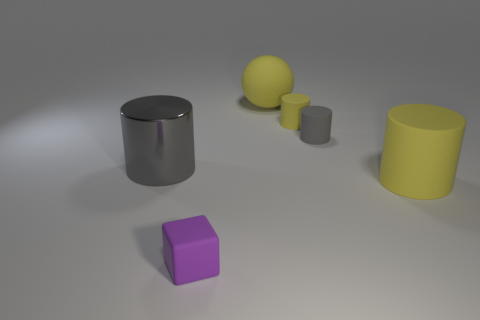Are there any other things that have the same material as the large gray cylinder?
Offer a very short reply. No. What number of things are either yellow cylinders that are in front of the tiny yellow rubber object or large green metallic objects?
Your answer should be compact. 1. Are there any purple rubber cubes that have the same size as the gray matte object?
Provide a succinct answer. Yes. What is the material of the yellow sphere that is the same size as the gray metal thing?
Offer a very short reply. Rubber. What shape is the tiny object that is both left of the small gray object and to the right of the yellow ball?
Give a very brief answer. Cylinder. There is a big object to the left of the rubber cube; what is its color?
Your answer should be compact. Gray. What size is the rubber thing that is both left of the tiny gray cylinder and in front of the tiny gray cylinder?
Your answer should be very brief. Small. Is the material of the large ball the same as the gray cylinder to the left of the tiny yellow cylinder?
Your answer should be compact. No. How many tiny objects are the same shape as the large gray shiny thing?
Your response must be concise. 2. There is a small object that is the same color as the large matte sphere; what is its material?
Offer a terse response. Rubber. 